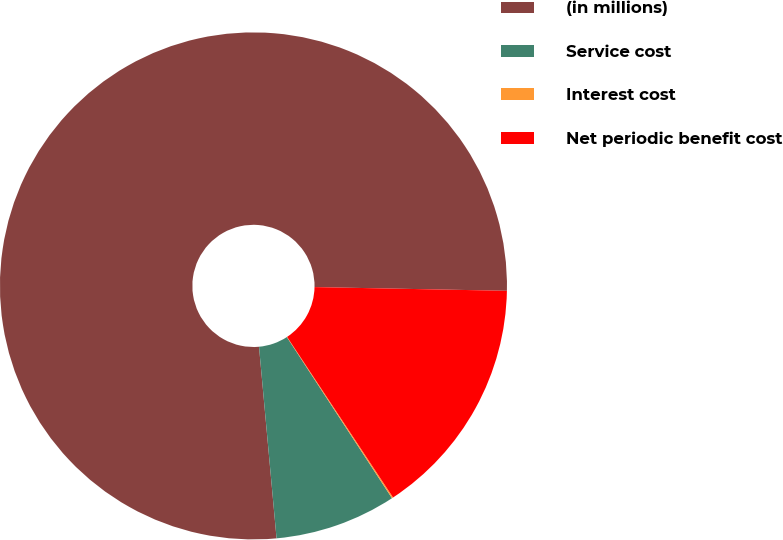Convert chart to OTSL. <chart><loc_0><loc_0><loc_500><loc_500><pie_chart><fcel>(in millions)<fcel>Service cost<fcel>Interest cost<fcel>Net periodic benefit cost<nl><fcel>76.76%<fcel>7.75%<fcel>0.08%<fcel>15.41%<nl></chart> 